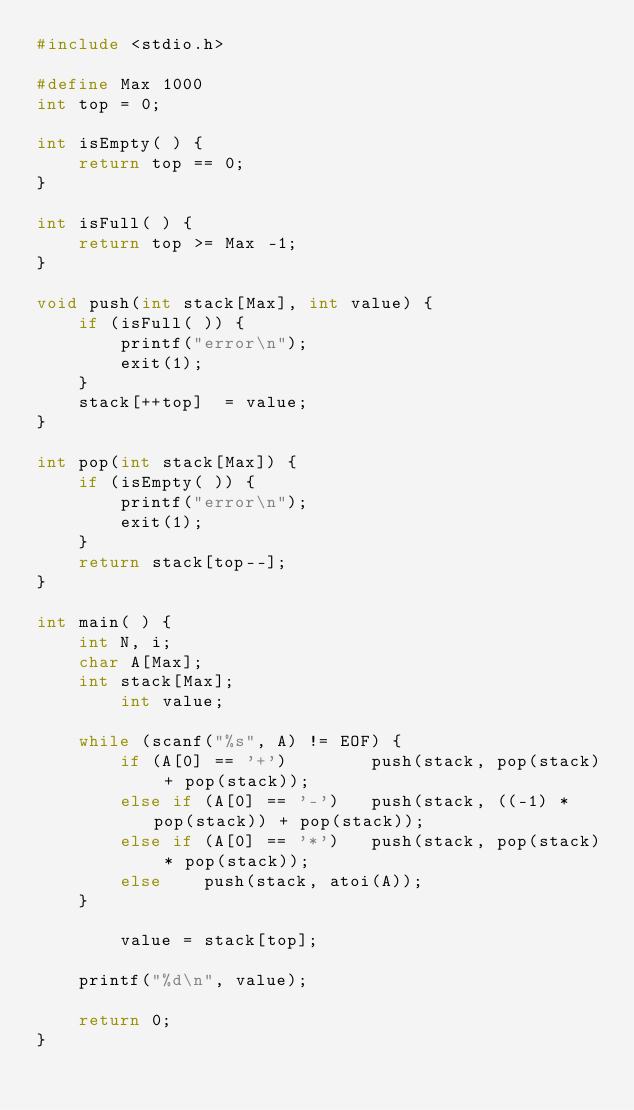<code> <loc_0><loc_0><loc_500><loc_500><_C_>#include <stdio.h>

#define Max 1000
int top = 0;

int isEmpty( ) {
	return top == 0;
}

int isFull( ) {
	return top >= Max -1;
}

void push(int stack[Max], int value) {
	if (isFull( )) {
		printf("error\n");
		exit(1);
	}
	stack[++top]  = value;
}

int pop(int stack[Max]) {
	if (isEmpty( )) {
		printf("error\n");
		exit(1);
	}
	return stack[top--];
}

int main( ) {
	int N, i;
	char A[Max];
	int stack[Max];
        int value;

	while (scanf("%s", A) != EOF) {
		if (A[0] == '+')		push(stack, pop(stack) + pop(stack));
		else if (A[0] == '-')	push(stack, ((-1) * pop(stack)) + pop(stack));
		else if (A[0] == '*')	push(stack, pop(stack) * pop(stack));
		else	push(stack, atoi(A));
	}

        value = stack[top];

	printf("%d\n", value);

	return 0;
}</code> 